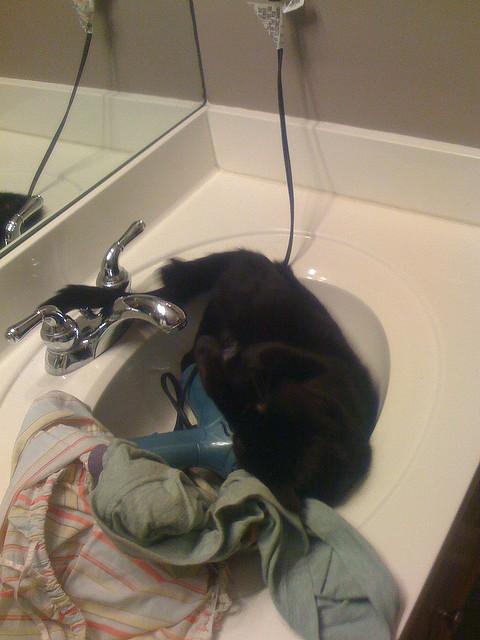Is there a cat in the sink?
Quick response, please. Yes. What is in the sink?
Be succinct. Cat. That is the black cat sitting on?
Short answer required. Sink. What room of the house is this?
Short answer required. Bathroom. 